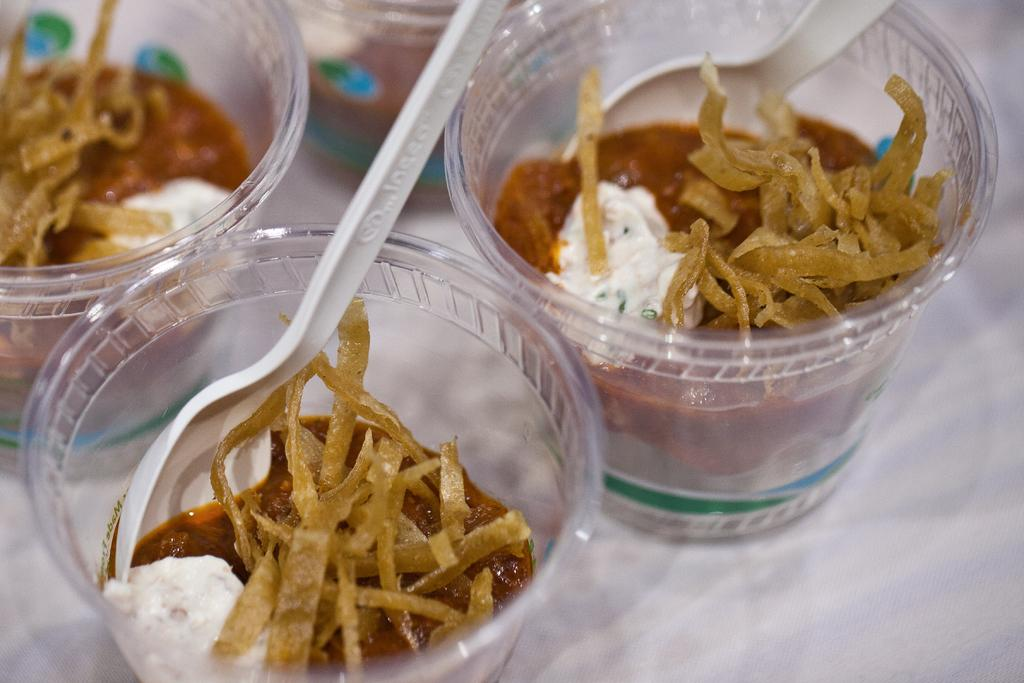How many cups are visible in the image? There are three transparent cups in the image. What is inside the cups? There is food in the cups. What utensil is present in the cups? There is a spoon in the cups. What type of cat can be seen sitting on the edge of the cup in the image? There is no cat present in the image; it only features three transparent cups with food and a spoon. 